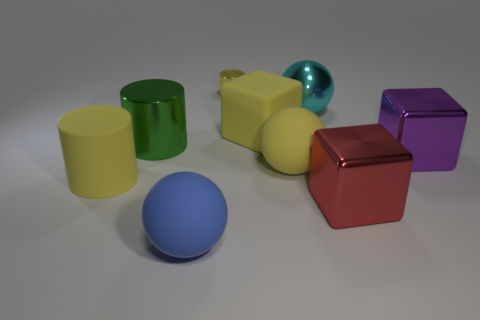Is there anything else that is the same size as the yellow metal cylinder?
Offer a terse response. No. How many purple shiny objects have the same shape as the large red shiny object?
Offer a very short reply. 1. Does the rubber block have the same color as the tiny object?
Your answer should be compact. Yes. Are there any big shiny cubes that have the same color as the tiny cylinder?
Make the answer very short. No. Is the large cylinder in front of the big green thing made of the same material as the purple thing to the right of the cyan shiny object?
Your answer should be very brief. No. What color is the shiny sphere?
Offer a very short reply. Cyan. How big is the yellow rubber object that is left of the yellow cylinder on the right side of the ball that is in front of the yellow matte cylinder?
Provide a short and direct response. Large. How many other objects are there of the same size as the green cylinder?
Your answer should be very brief. 7. What number of big blue balls are made of the same material as the large cyan thing?
Offer a terse response. 0. There is a thing that is behind the cyan metal ball; what shape is it?
Your response must be concise. Cylinder. 